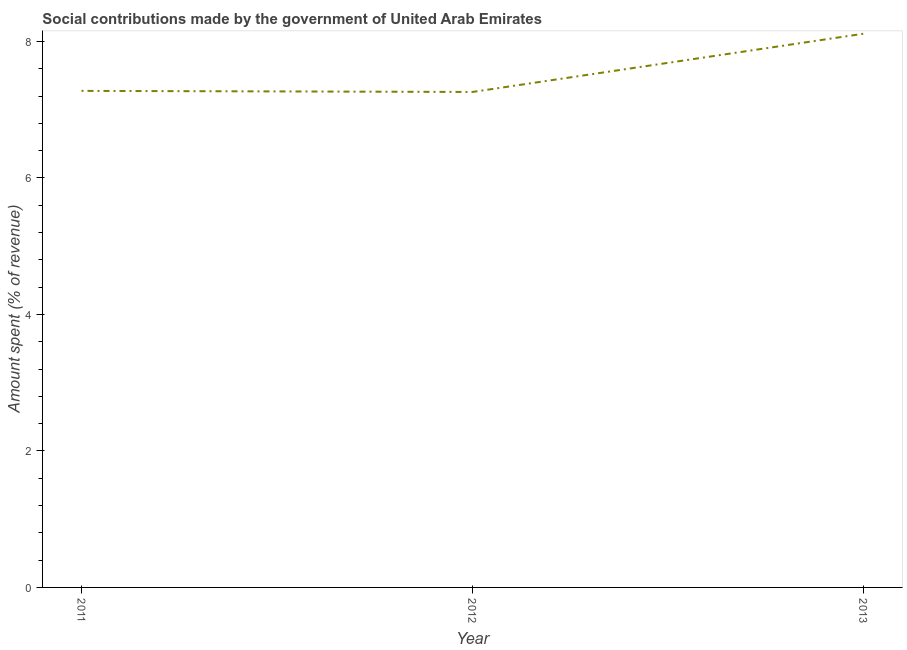What is the amount spent in making social contributions in 2011?
Provide a succinct answer. 7.28. Across all years, what is the maximum amount spent in making social contributions?
Offer a terse response. 8.11. Across all years, what is the minimum amount spent in making social contributions?
Provide a short and direct response. 7.26. What is the sum of the amount spent in making social contributions?
Give a very brief answer. 22.65. What is the difference between the amount spent in making social contributions in 2011 and 2013?
Give a very brief answer. -0.84. What is the average amount spent in making social contributions per year?
Your answer should be compact. 7.55. What is the median amount spent in making social contributions?
Provide a short and direct response. 7.28. In how many years, is the amount spent in making social contributions greater than 2 %?
Ensure brevity in your answer.  3. Do a majority of the years between 2013 and 2012 (inclusive) have amount spent in making social contributions greater than 0.4 %?
Provide a succinct answer. No. What is the ratio of the amount spent in making social contributions in 2011 to that in 2012?
Keep it short and to the point. 1. Is the amount spent in making social contributions in 2011 less than that in 2012?
Provide a succinct answer. No. What is the difference between the highest and the second highest amount spent in making social contributions?
Offer a very short reply. 0.84. What is the difference between the highest and the lowest amount spent in making social contributions?
Offer a very short reply. 0.85. How many lines are there?
Provide a succinct answer. 1. What is the difference between two consecutive major ticks on the Y-axis?
Your answer should be compact. 2. Are the values on the major ticks of Y-axis written in scientific E-notation?
Provide a succinct answer. No. Does the graph contain any zero values?
Provide a short and direct response. No. Does the graph contain grids?
Offer a very short reply. No. What is the title of the graph?
Provide a short and direct response. Social contributions made by the government of United Arab Emirates. What is the label or title of the X-axis?
Ensure brevity in your answer.  Year. What is the label or title of the Y-axis?
Offer a very short reply. Amount spent (% of revenue). What is the Amount spent (% of revenue) in 2011?
Provide a short and direct response. 7.28. What is the Amount spent (% of revenue) of 2012?
Make the answer very short. 7.26. What is the Amount spent (% of revenue) in 2013?
Offer a very short reply. 8.11. What is the difference between the Amount spent (% of revenue) in 2011 and 2012?
Offer a very short reply. 0.02. What is the difference between the Amount spent (% of revenue) in 2011 and 2013?
Your response must be concise. -0.84. What is the difference between the Amount spent (% of revenue) in 2012 and 2013?
Give a very brief answer. -0.85. What is the ratio of the Amount spent (% of revenue) in 2011 to that in 2012?
Your answer should be compact. 1. What is the ratio of the Amount spent (% of revenue) in 2011 to that in 2013?
Offer a terse response. 0.9. What is the ratio of the Amount spent (% of revenue) in 2012 to that in 2013?
Give a very brief answer. 0.9. 